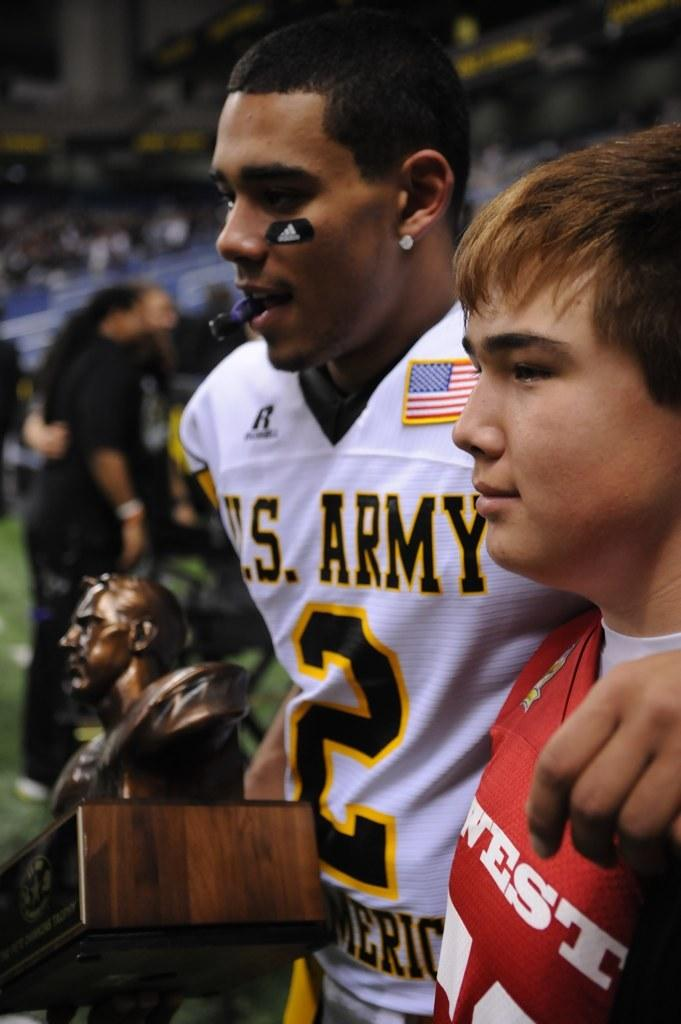<image>
Relay a brief, clear account of the picture shown. A football player from the Army team poses for a photo with a fan while holding a trophy. 